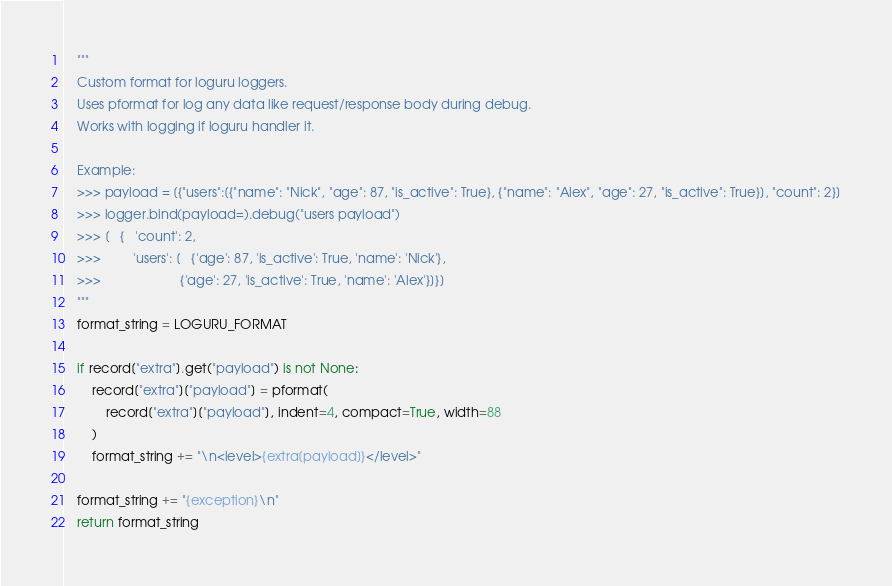Convert code to text. <code><loc_0><loc_0><loc_500><loc_500><_Python_>    """
    Custom format for loguru loggers.
    Uses pformat for log any data like request/response body during debug.
    Works with logging if loguru handler it.

    Example:
    >>> payload = [{"users":[{"name": "Nick", "age": 87, "is_active": True}, {"name": "Alex", "age": 27, "is_active": True}], "count": 2}]
    >>> logger.bind(payload=).debug("users payload")
    >>> [   {   'count': 2,
    >>>         'users': [   {'age': 87, 'is_active': True, 'name': 'Nick'},
    >>>                      {'age': 27, 'is_active': True, 'name': 'Alex'}]}]
    """
    format_string = LOGURU_FORMAT

    if record["extra"].get("payload") is not None:
        record["extra"]["payload"] = pformat(
            record["extra"]["payload"], indent=4, compact=True, width=88
        )
        format_string += "\n<level>{extra[payload]}</level>"

    format_string += "{exception}\n"
    return format_string
</code> 